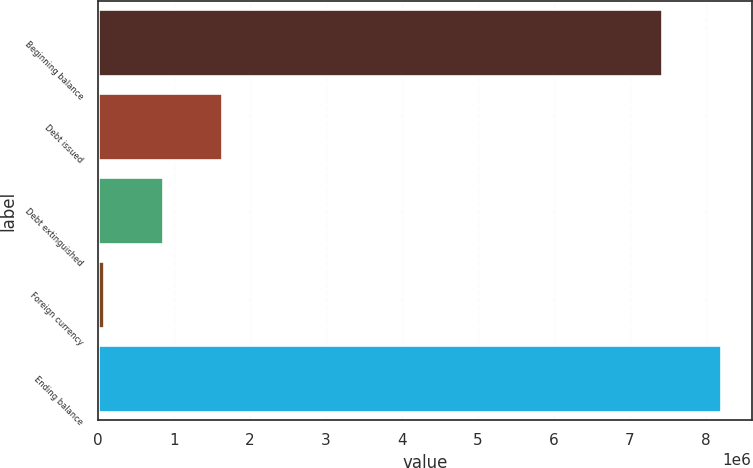Convert chart. <chart><loc_0><loc_0><loc_500><loc_500><bar_chart><fcel>Beginning balance<fcel>Debt issued<fcel>Debt extinguished<fcel>Foreign currency<fcel>Ending balance<nl><fcel>7.42171e+06<fcel>1.63195e+06<fcel>858798<fcel>85647<fcel>8.19486e+06<nl></chart> 